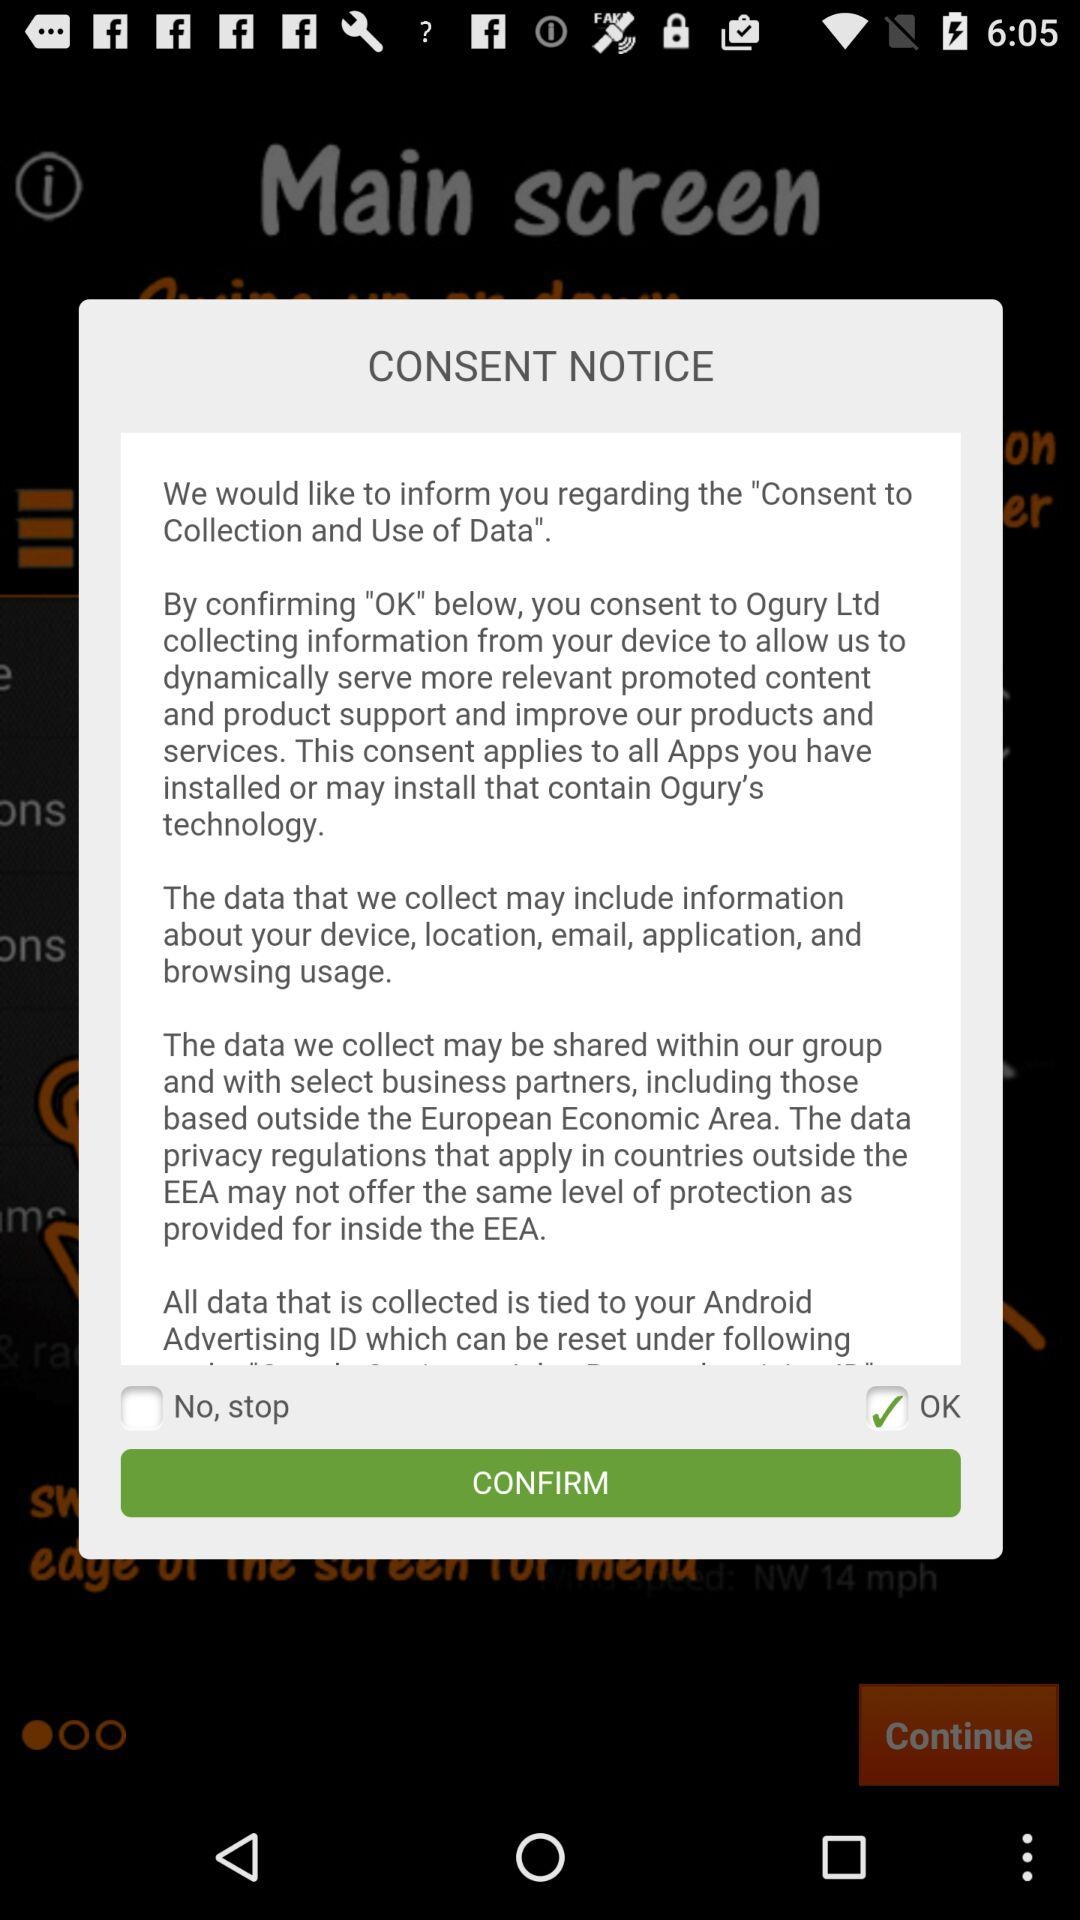What is the status of "No, stop"? The status of "No, stop" is "off". 